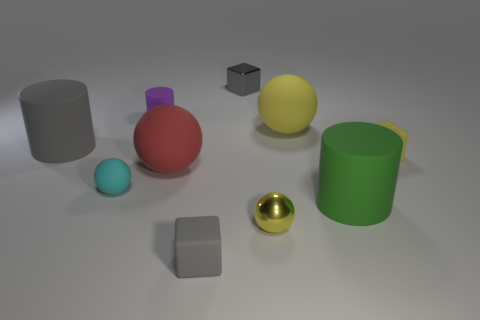Subtract all balls. How many objects are left? 6 Subtract all tiny yellow objects. Subtract all big objects. How many objects are left? 4 Add 2 matte cubes. How many matte cubes are left? 4 Add 5 big yellow rubber cylinders. How many big yellow rubber cylinders exist? 5 Subtract 2 gray cubes. How many objects are left? 8 